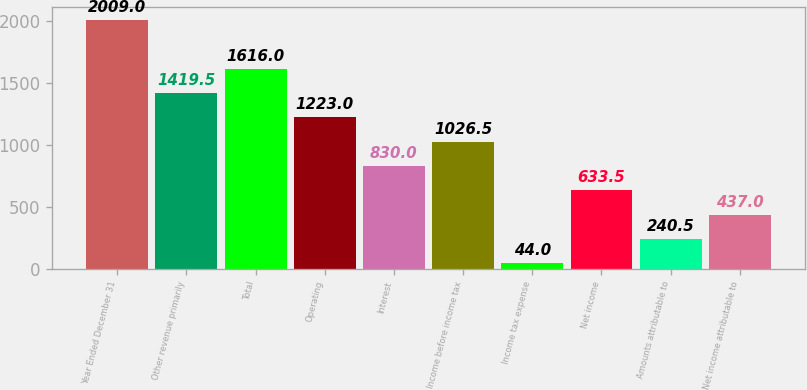Convert chart to OTSL. <chart><loc_0><loc_0><loc_500><loc_500><bar_chart><fcel>Year Ended December 31<fcel>Other revenue primarily<fcel>Total<fcel>Operating<fcel>Interest<fcel>Income before income tax<fcel>Income tax expense<fcel>Net income<fcel>Amounts attributable to<fcel>Net income attributable to<nl><fcel>2009<fcel>1419.5<fcel>1616<fcel>1223<fcel>830<fcel>1026.5<fcel>44<fcel>633.5<fcel>240.5<fcel>437<nl></chart> 